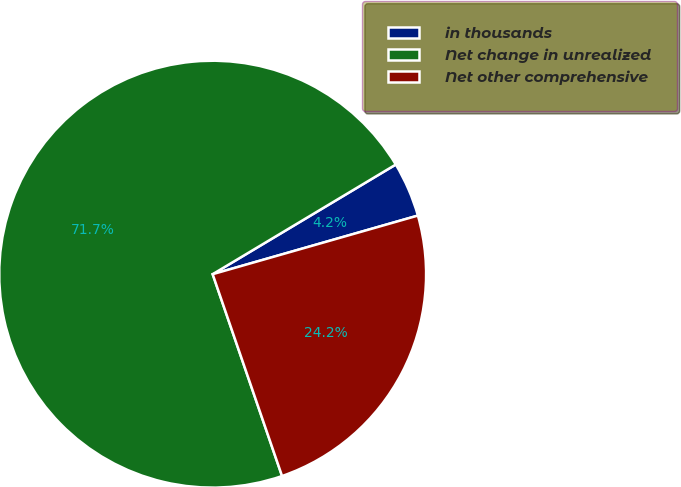<chart> <loc_0><loc_0><loc_500><loc_500><pie_chart><fcel>in thousands<fcel>Net change in unrealized<fcel>Net other comprehensive<nl><fcel>4.16%<fcel>71.69%<fcel>24.16%<nl></chart> 